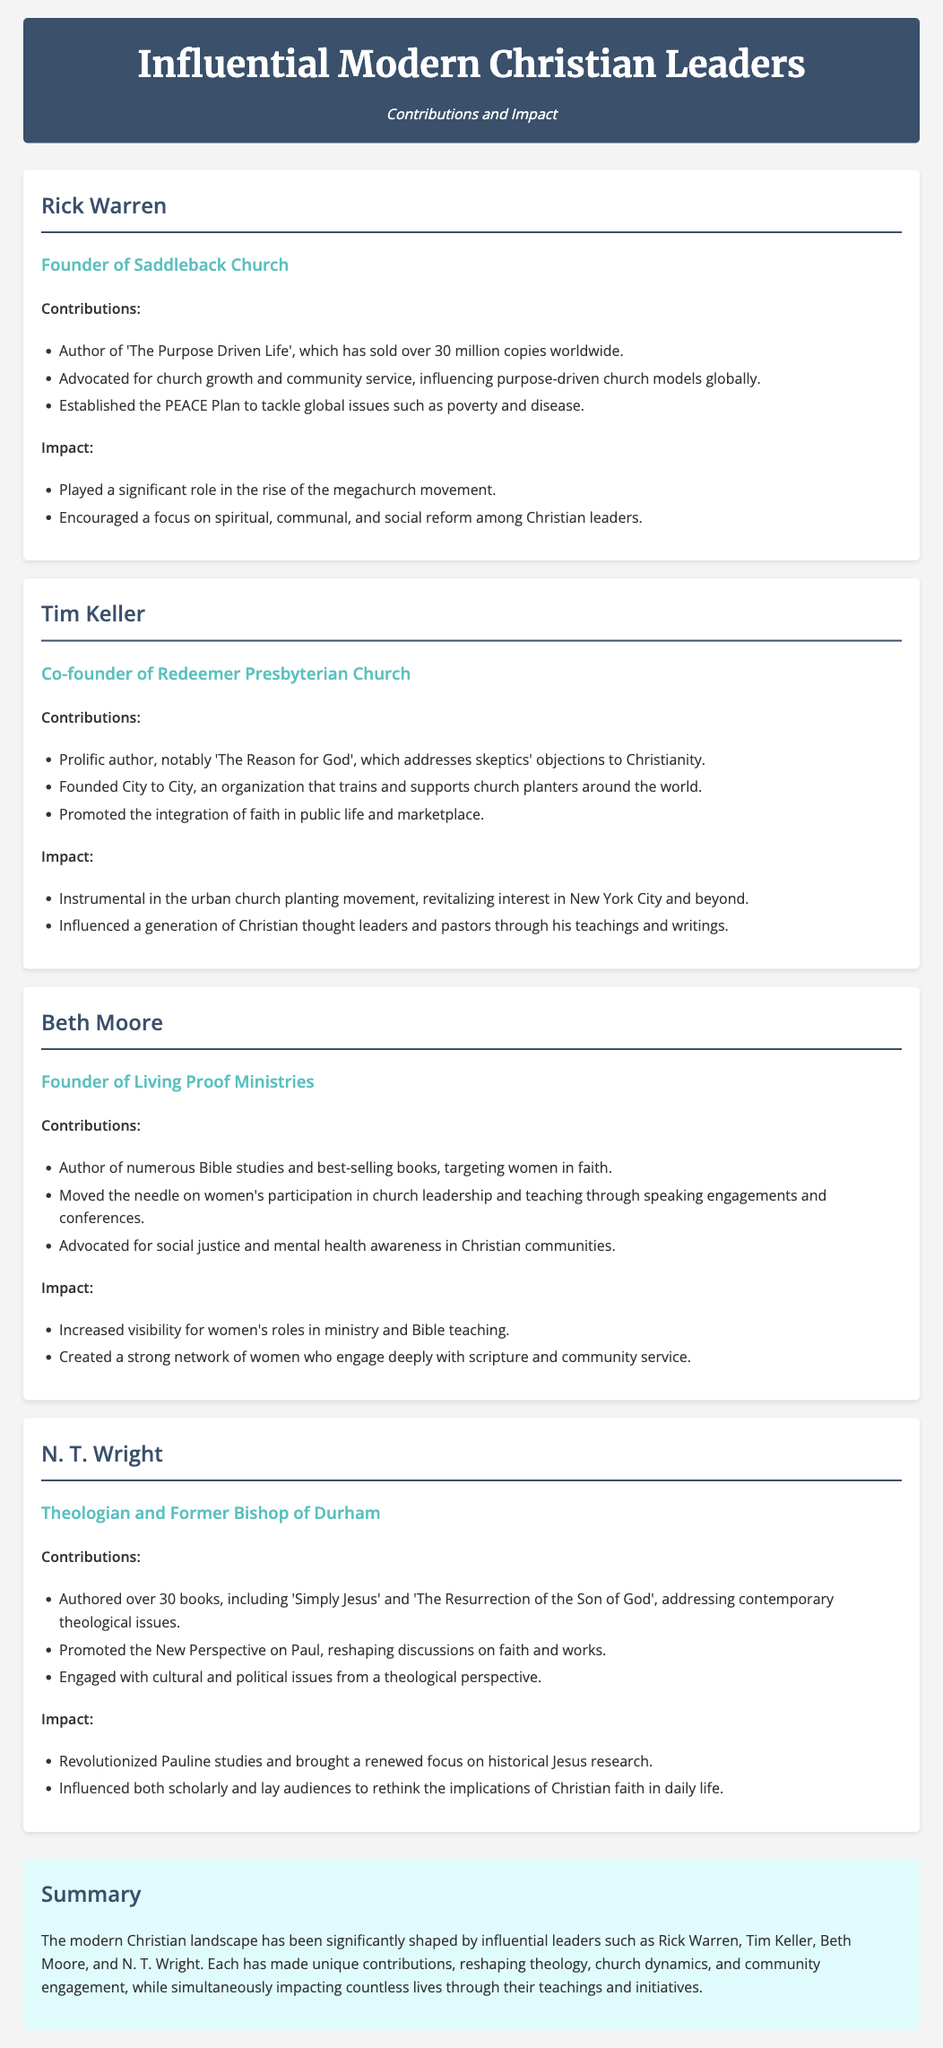What is the title of Rick Warren's best-selling book? The document states that Rick Warren authored 'The Purpose Driven Life', which is noted as a best-selling book.
Answer: The Purpose Driven Life Who is the founder of Living Proof Ministries? The document identifies Beth Moore as the founder of Living Proof Ministries.
Answer: Beth Moore How many books has N. T. Wright authored? The document mentions that N. T. Wright has authored over 30 books.
Answer: over 30 What movement did Tim Keller contribute to revitalizing? The document states that Tim Keller was instrumental in the urban church planting movement, specifically in New York City.
Answer: urban church planting movement Which leader advocated for social justice and mental health awareness? According to the document, Beth Moore advocated for social justice and mental health awareness in Christian communities.
Answer: Beth Moore What initiative did Rick Warren establish to address global issues? The document refers to the PEACE Plan, established by Rick Warren, to tackle global issues such as poverty and disease.
Answer: PEACE Plan What is one of the focuses of Tim Keller's writings? The document notes that Tim Keller emphasizes the integration of faith in public life and the marketplace.
Answer: integration of faith in public life How has Beth Moore impacted women's roles in ministry? The document states that Beth Moore increased visibility for women's roles in ministry and Bible teaching.
Answer: increased visibility Who promoted the New Perspective on Paul? N. T. Wright is identified in the document as the one who promoted the New Perspective on Paul.
Answer: N. T. Wright What is the theme of the summary in the document? The summary highlights that influential leaders have reshaped theology, church dynamics, and community engagement.
Answer: reshaped theology, church dynamics, and community engagement 